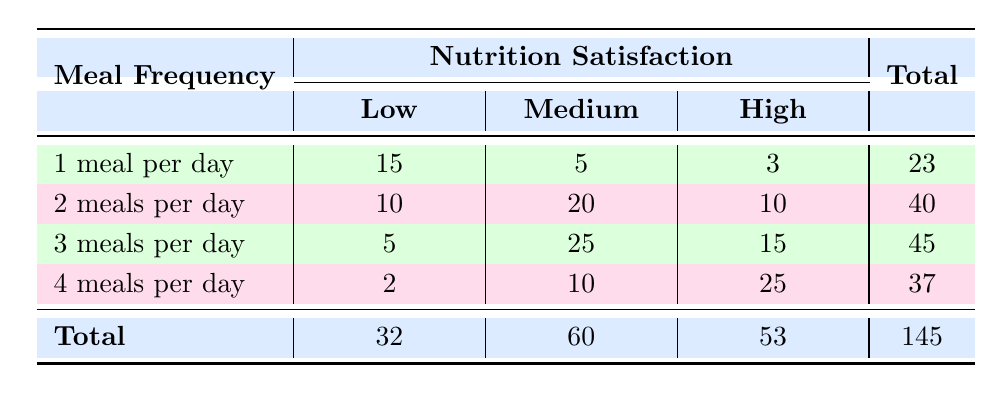What is the total number of participants who rated their nutrition satisfaction as high? To find the total number of participants who rated their nutrition satisfaction as high, we sum up the counts for the "High" ratings from all meal frequencies: 3 (1 meal per day) + 10 (2 meals per day) + 15 (3 meals per day) + 25 (4 meals per day) = 53.
Answer: 53 How many participants were satisfied with their nutrition at a medium level for 2 meals per day? The number of participants who rated their nutrition satisfaction as medium while having 2 meals per day is given directly in the table, which is 20.
Answer: 20 What is the difference in the total number of participants between those who had 3 meals per day and those who had 4 meals per day? First, we find the total participants for both meal frequencies: 3 meals per day has 45 participants and 4 meals per day has 37 participants. Then we calculate the difference: 45 - 37 = 8.
Answer: 8 Is it true that more participants were satisfied with their nutrition at a low level for 1 meal per day than for 4 meals per day? The table shows that 15 participants rated their nutrition satisfaction as low for 1 meal per day, while only 2 participants rated it as low for 4 meals per day. Since 15 is greater than 2, the statement is true.
Answer: Yes What is the average number of participants in each satisfaction rating category across all meal frequencies? We total the participants for each satisfaction rating: Low (32), Medium (60), High (53). There are 3 categories, so we calculate the averages: Low is 32/4 = 8, Medium is 60/4 = 15, High is 53/4 = ~13.25.
Answer: Low: 8, Medium: 15, High: 13.25 